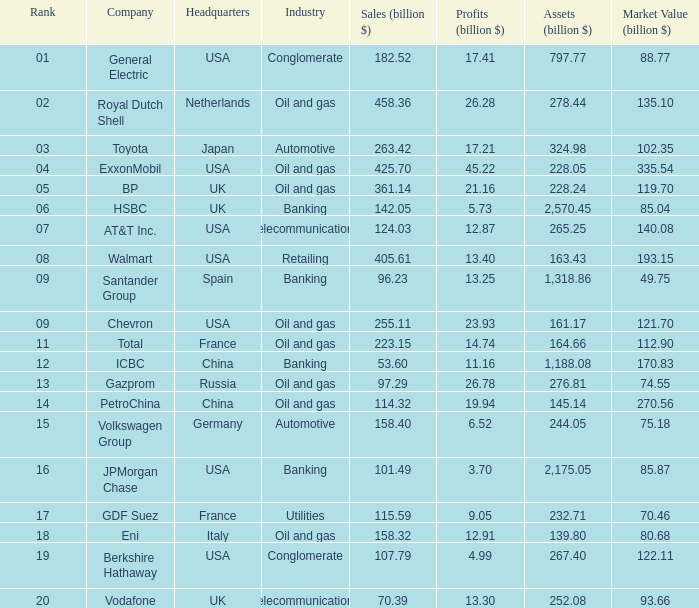Name the lowest Profits (billion $) which has a Sales (billion $) of 425.7, and a Rank larger than 4? None. Parse the table in full. {'header': ['Rank', 'Company', 'Headquarters', 'Industry', 'Sales (billion $)', 'Profits (billion $)', 'Assets (billion $)', 'Market Value (billion $)'], 'rows': [['01', 'General Electric', 'USA', 'Conglomerate', '182.52', '17.41', '797.77', '88.77'], ['02', 'Royal Dutch Shell', 'Netherlands', 'Oil and gas', '458.36', '26.28', '278.44', '135.10'], ['03', 'Toyota', 'Japan', 'Automotive', '263.42', '17.21', '324.98', '102.35'], ['04', 'ExxonMobil', 'USA', 'Oil and gas', '425.70', '45.22', '228.05', '335.54'], ['05', 'BP', 'UK', 'Oil and gas', '361.14', '21.16', '228.24', '119.70'], ['06', 'HSBC', 'UK', 'Banking', '142.05', '5.73', '2,570.45', '85.04'], ['07', 'AT&T Inc.', 'USA', 'Telecommunications', '124.03', '12.87', '265.25', '140.08'], ['08', 'Walmart', 'USA', 'Retailing', '405.61', '13.40', '163.43', '193.15'], ['09', 'Santander Group', 'Spain', 'Banking', '96.23', '13.25', '1,318.86', '49.75'], ['09', 'Chevron', 'USA', 'Oil and gas', '255.11', '23.93', '161.17', '121.70'], ['11', 'Total', 'France', 'Oil and gas', '223.15', '14.74', '164.66', '112.90'], ['12', 'ICBC', 'China', 'Banking', '53.60', '11.16', '1,188.08', '170.83'], ['13', 'Gazprom', 'Russia', 'Oil and gas', '97.29', '26.78', '276.81', '74.55'], ['14', 'PetroChina', 'China', 'Oil and gas', '114.32', '19.94', '145.14', '270.56'], ['15', 'Volkswagen Group', 'Germany', 'Automotive', '158.40', '6.52', '244.05', '75.18'], ['16', 'JPMorgan Chase', 'USA', 'Banking', '101.49', '3.70', '2,175.05', '85.87'], ['17', 'GDF Suez', 'France', 'Utilities', '115.59', '9.05', '232.71', '70.46'], ['18', 'Eni', 'Italy', 'Oil and gas', '158.32', '12.91', '139.80', '80.68'], ['19', 'Berkshire Hathaway', 'USA', 'Conglomerate', '107.79', '4.99', '267.40', '122.11'], ['20', 'Vodafone', 'UK', 'Telecommunications', '70.39', '13.30', '252.08', '93.66']]} 